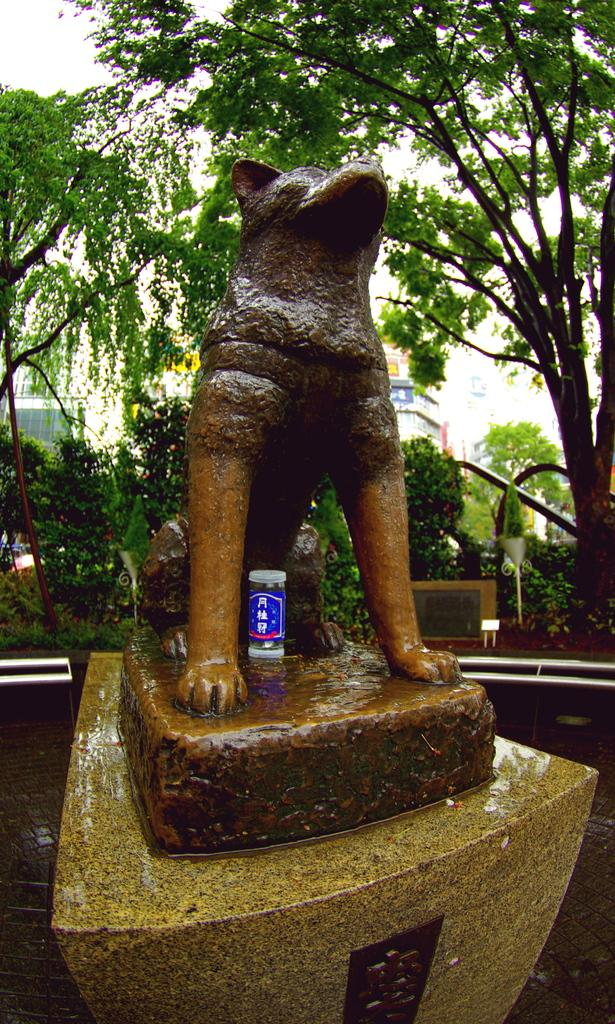What is the main subject in the center of the image? There is a statue in the center of the image. What is placed in front of the statue? There is a tin placed in front of the statue. What type of vegetation can be seen in the image? There are plants and a group of trees visible in the image. What type of structure is present in the image? There is a building in the image. What is visible in the background of the image? The sky is visible in the image. How many leaves are on the statue in the image? There are no leaves present on the statue in the image. 